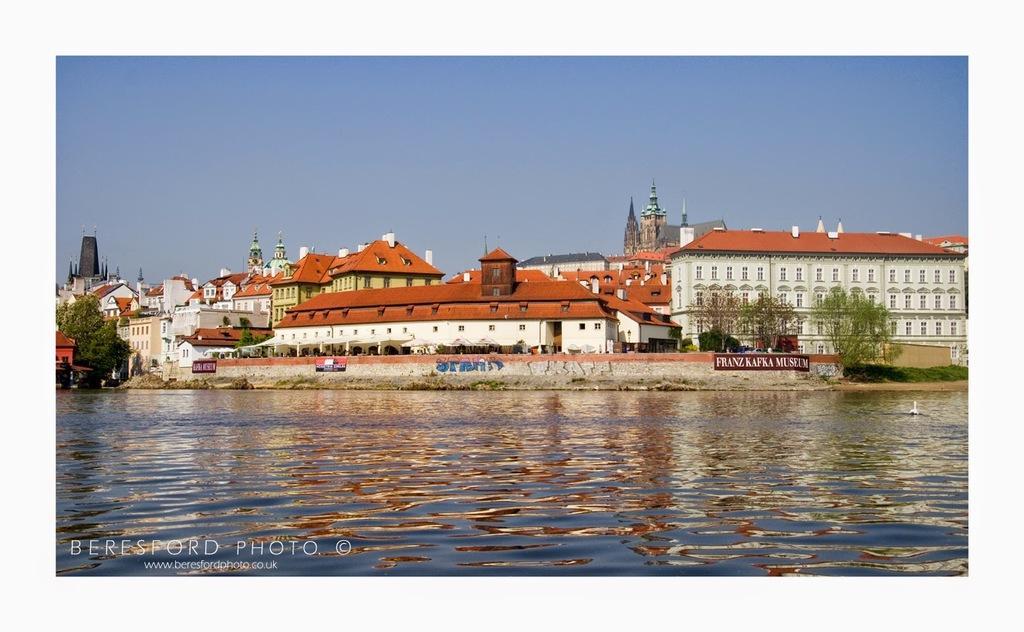How would you summarize this image in a sentence or two? In the center of the image we can see buildings, trees, boards, wall, windows are present. At the bottom of the image water is there. At the top of the image sky is there. 